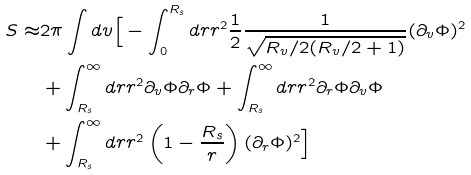Convert formula to latex. <formula><loc_0><loc_0><loc_500><loc_500>S \approx & 2 \pi \int d v \Big { [ } - \int _ { 0 } ^ { R _ { s } } d r r ^ { 2 } \frac { 1 } { 2 } \frac { 1 } { \sqrt { R _ { v } / 2 ( R _ { v } / 2 + 1 ) } } ( \partial _ { v } \Phi ) ^ { 2 } \\ & + \int _ { R _ { s } } ^ { \infty } d r r ^ { 2 } \partial _ { v } \Phi \partial _ { r } \Phi + \int _ { R _ { s } } ^ { \infty } d r r ^ { 2 } \partial _ { r } \Phi \partial _ { v } \Phi \\ & + \int _ { R _ { s } } ^ { \infty } d r r ^ { 2 } \left ( 1 - \frac { R _ { s } } { r } \right ) ( \partial _ { r } \Phi ) ^ { 2 } \Big { ] }</formula> 